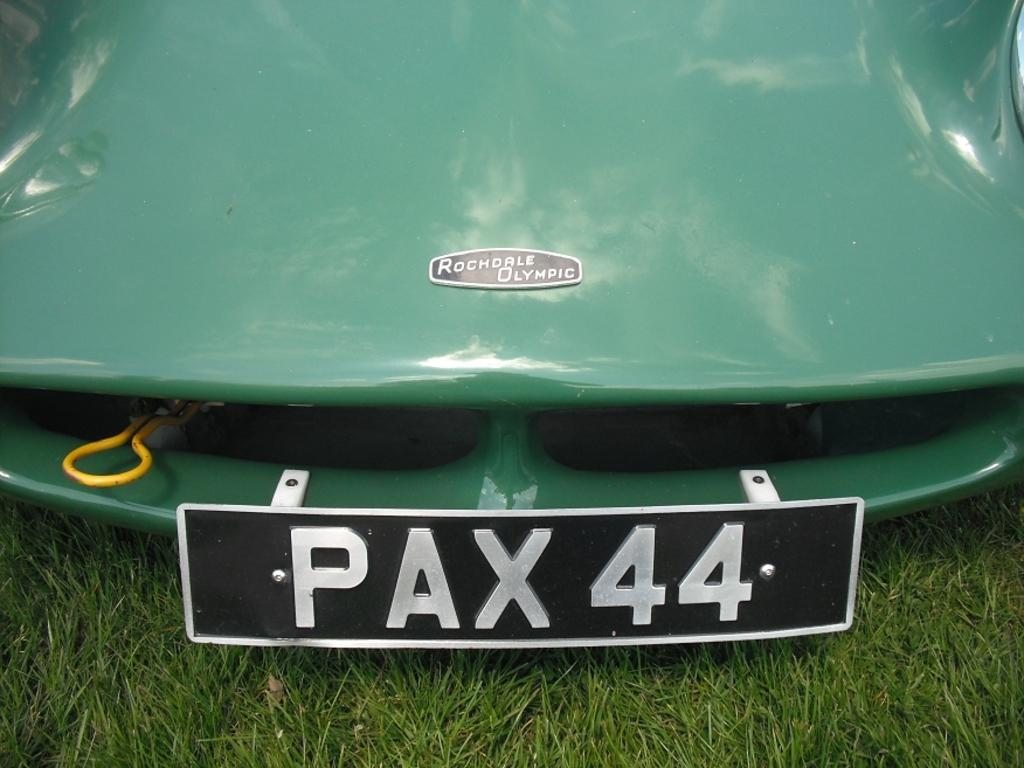<image>
Describe the image concisely. A green vehicle named Rochdale Olympic with the tag number PAX44. 